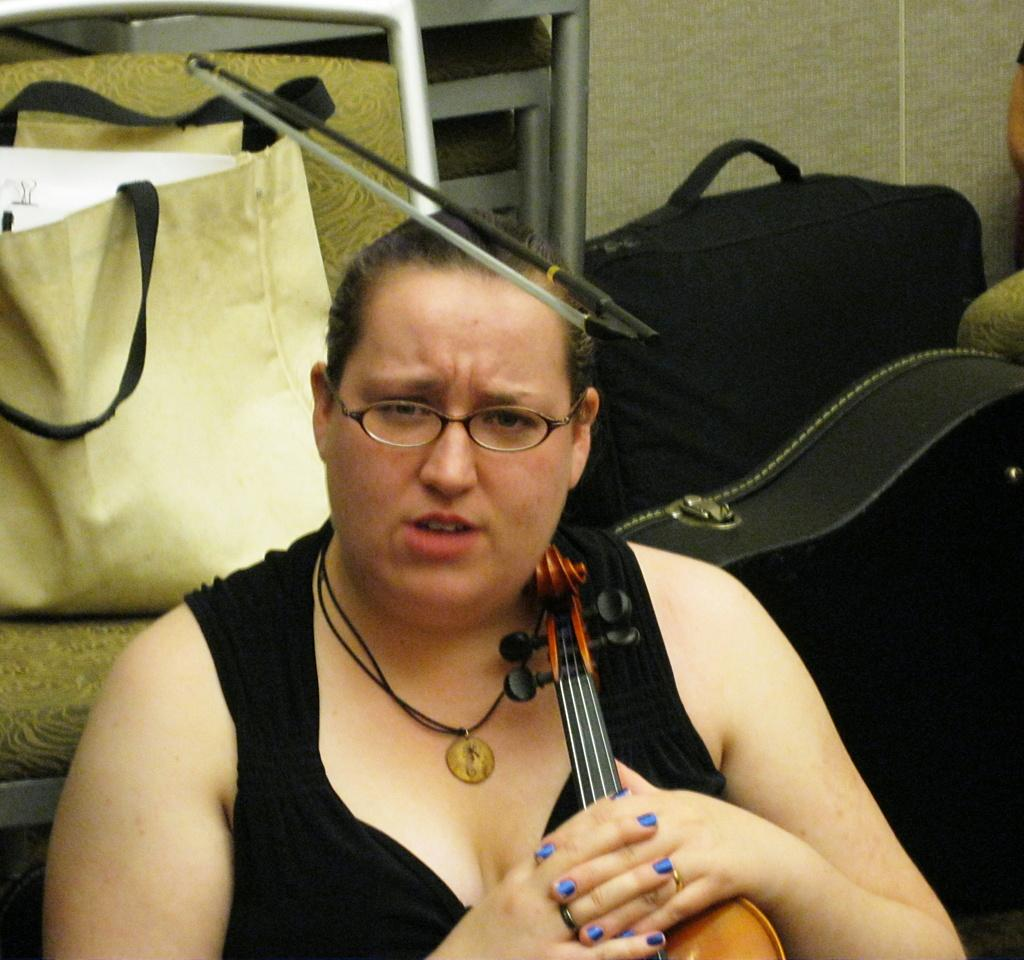Who is present in the image? There is a woman in the image. What is the woman holding in her hand? The woman is holding a violin in her hand. Can you describe any additional items visible in the image? There is baggage visible in the image. What type of bun is the woman wearing on her head in the image? There is no bun visible on the woman's head in the image. What role does the calculator play in the image? There is no calculator present in the image. 